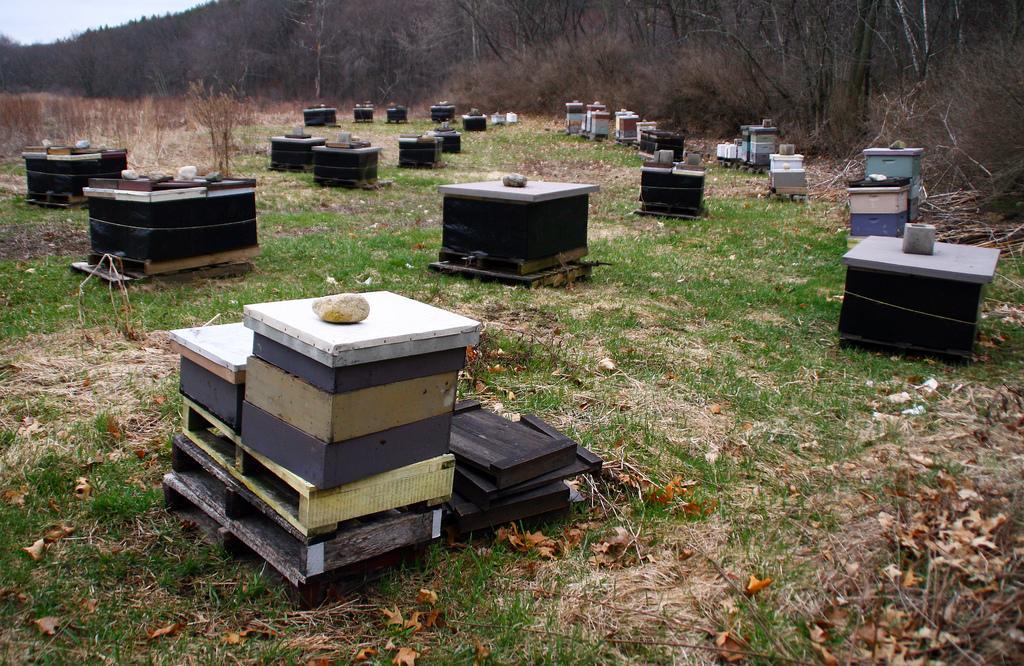Describe this image in one or two sentences. In the image there are wooden boxes on the grass surface, behind the boxes there are dry plants and trees. 